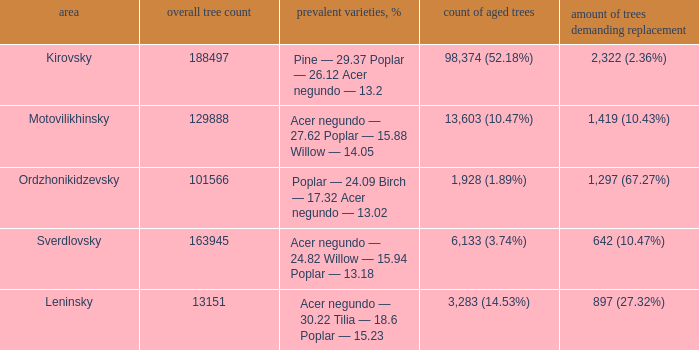What is the district when the total amount of trees is smaller than 150817.6878461314 and amount of old trees is 1,928 (1.89%)? Ordzhonikidzevsky. 